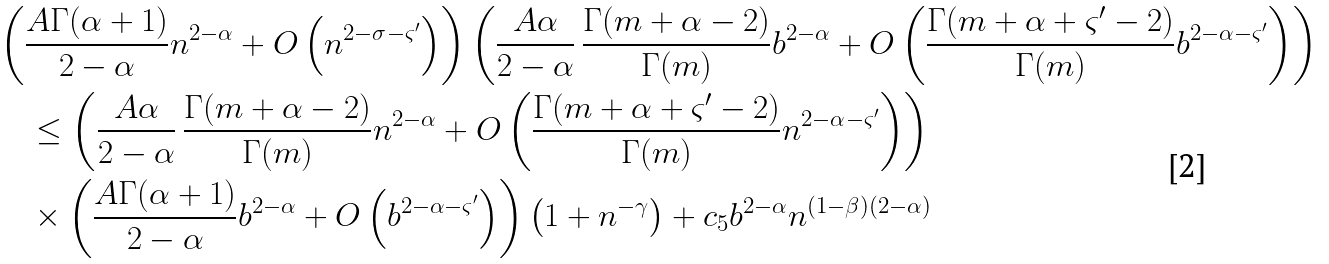<formula> <loc_0><loc_0><loc_500><loc_500>& \left ( \frac { A \Gamma ( \alpha + 1 ) } { 2 - \alpha } n ^ { 2 - \alpha } + O \left ( n ^ { 2 - \sigma - \varsigma ^ { \prime } } \right ) \right ) \left ( \frac { A \alpha } { 2 - \alpha } \, \frac { \Gamma ( m + \alpha - 2 ) } { \Gamma ( m ) } b ^ { 2 - \alpha } + O \left ( \frac { \Gamma ( m + \alpha + \varsigma ^ { \prime } - 2 ) } { \Gamma ( m ) } b ^ { 2 - \alpha - \varsigma ^ { \prime } } \right ) \right ) \\ & \quad \leq \left ( \frac { A \alpha } { 2 - \alpha } \, \frac { \Gamma ( m + \alpha - 2 ) } { \Gamma ( m ) } n ^ { 2 - \alpha } + O \left ( \frac { \Gamma ( m + \alpha + \varsigma ^ { \prime } - 2 ) } { \Gamma ( m ) } n ^ { 2 - \alpha - \varsigma ^ { \prime } } \right ) \right ) \\ & \quad \times \left ( \frac { A \Gamma ( \alpha + 1 ) } { 2 - \alpha } b ^ { 2 - \alpha } + O \left ( b ^ { 2 - \alpha - \varsigma ^ { \prime } } \right ) \right ) \left ( 1 + n ^ { - \gamma } \right ) + c _ { 5 } b ^ { 2 - \alpha } n ^ { ( 1 - \beta ) ( 2 - \alpha ) }</formula> 